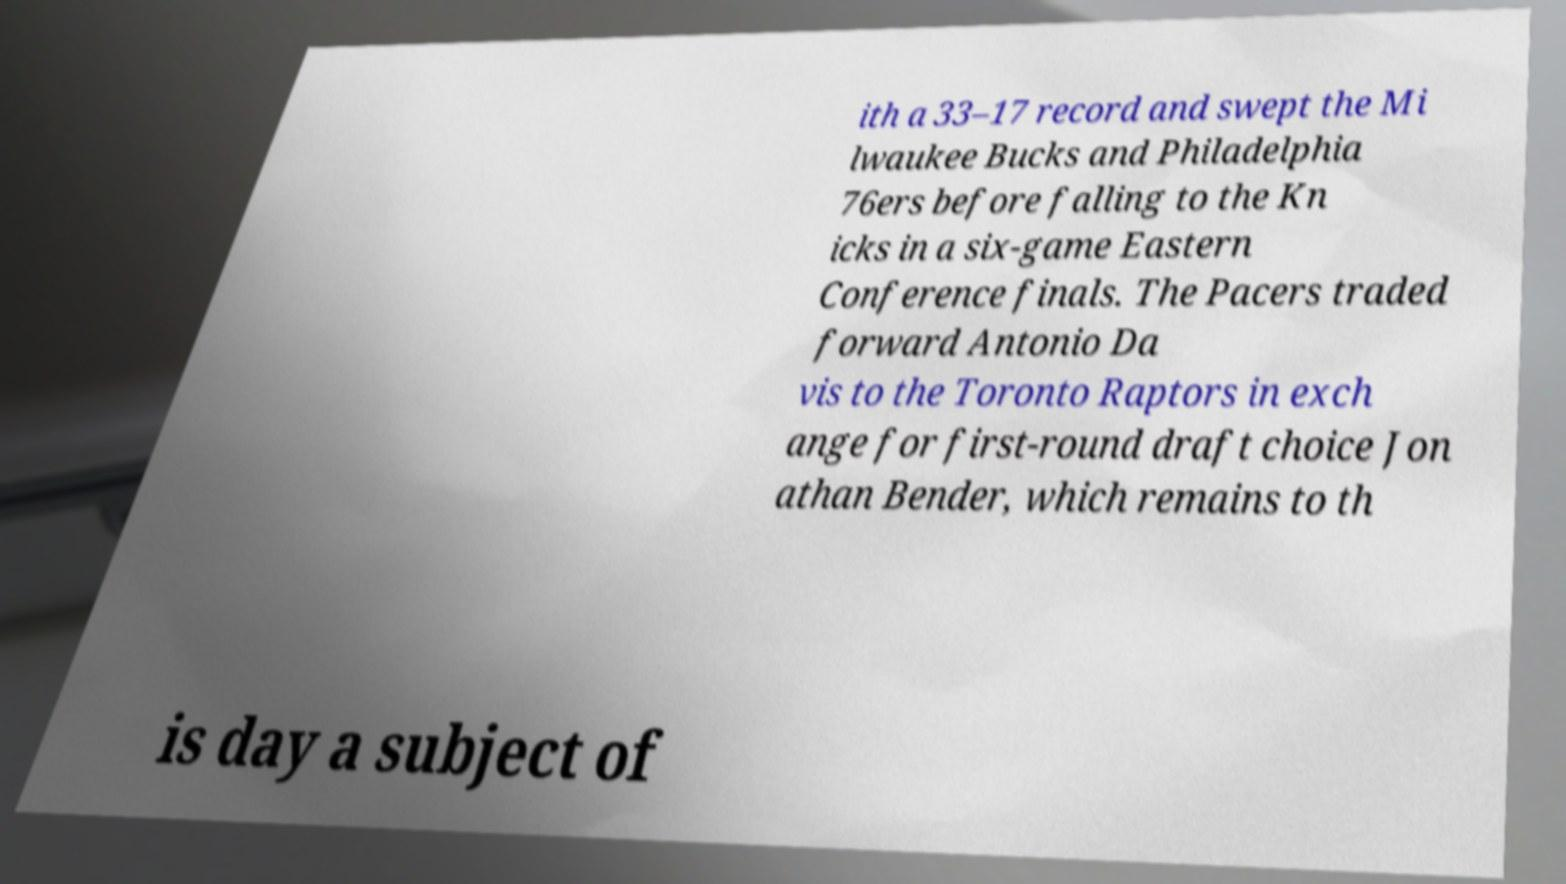Can you read and provide the text displayed in the image?This photo seems to have some interesting text. Can you extract and type it out for me? ith a 33–17 record and swept the Mi lwaukee Bucks and Philadelphia 76ers before falling to the Kn icks in a six-game Eastern Conference finals. The Pacers traded forward Antonio Da vis to the Toronto Raptors in exch ange for first-round draft choice Jon athan Bender, which remains to th is day a subject of 